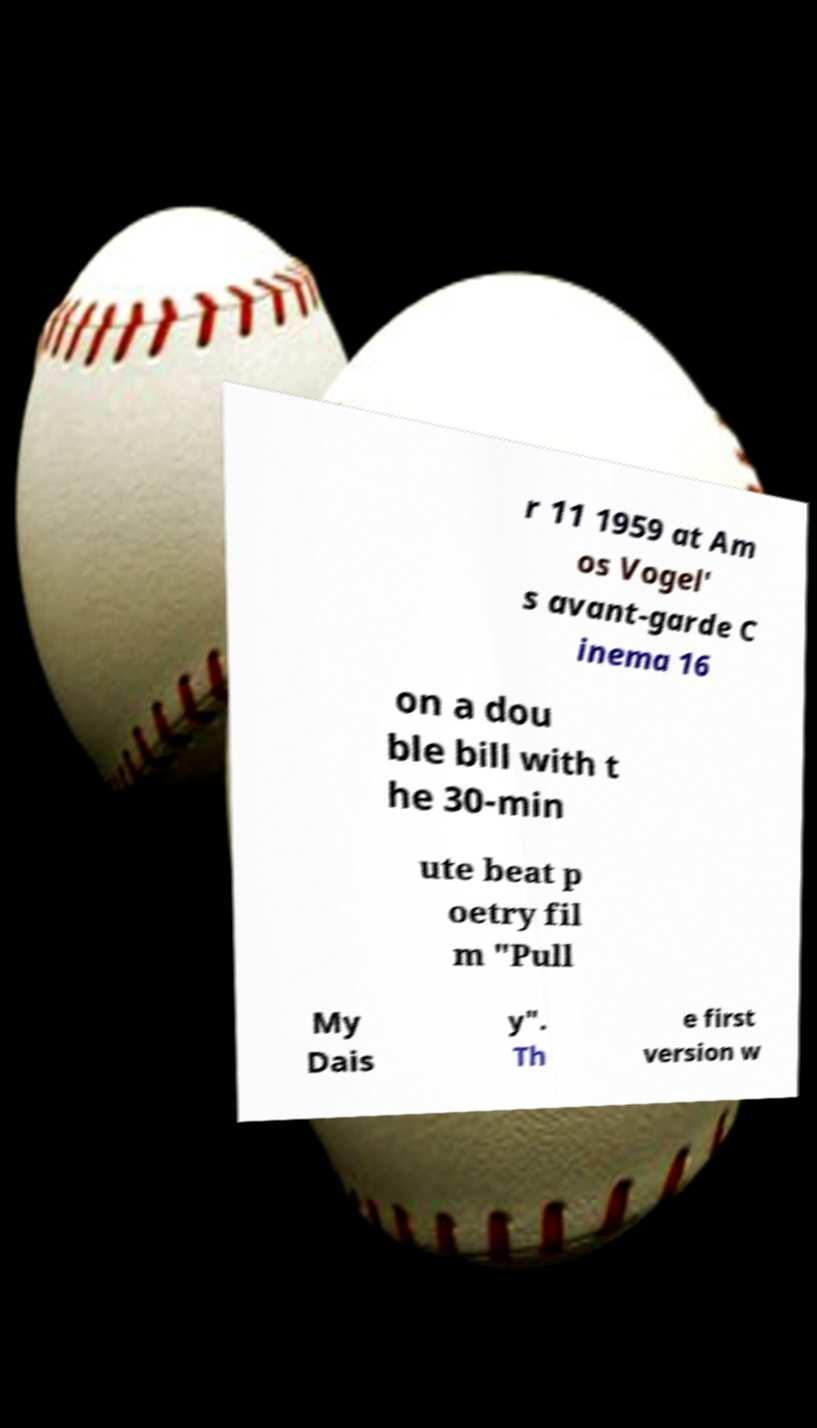Can you read and provide the text displayed in the image?This photo seems to have some interesting text. Can you extract and type it out for me? r 11 1959 at Am os Vogel' s avant-garde C inema 16 on a dou ble bill with t he 30-min ute beat p oetry fil m "Pull My Dais y". Th e first version w 